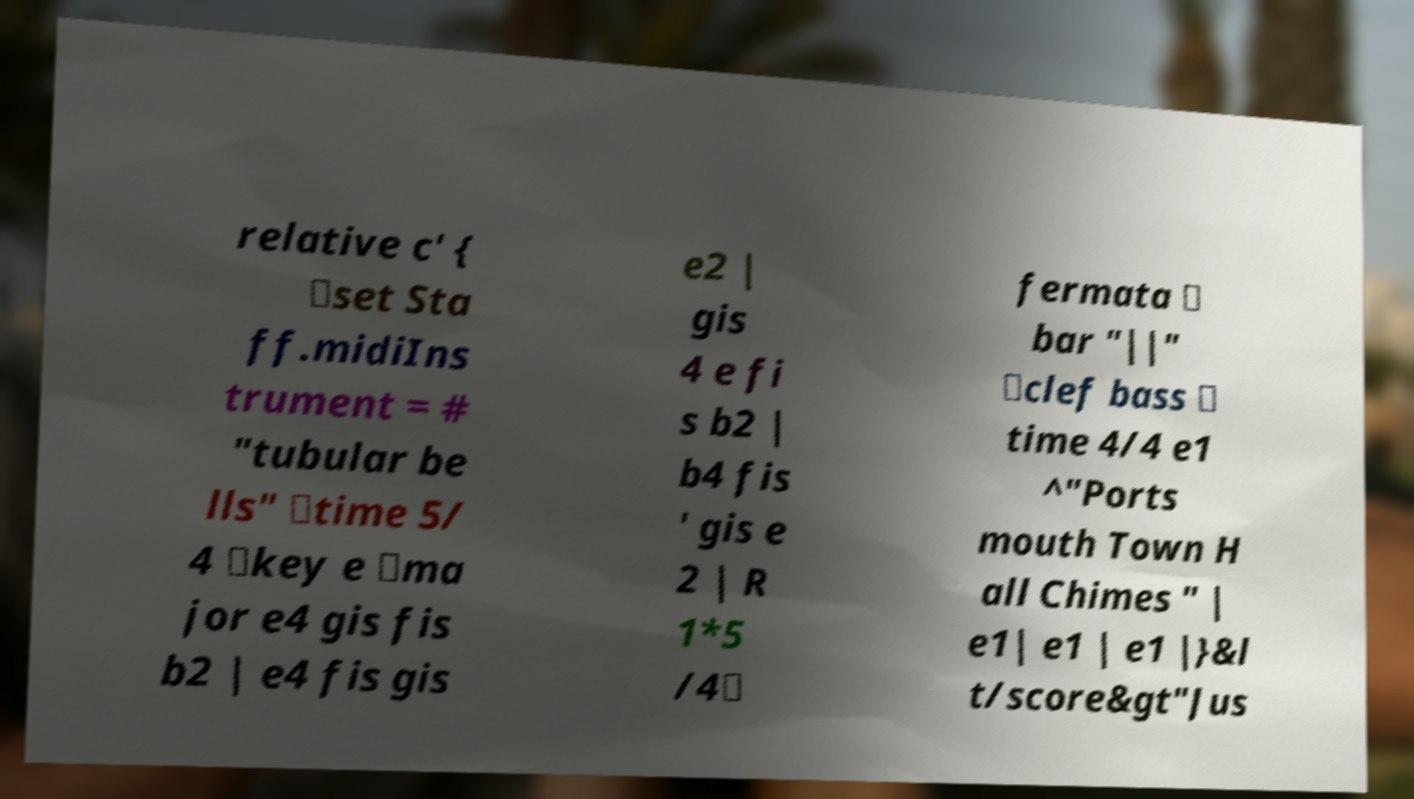I need the written content from this picture converted into text. Can you do that? relative c' { \set Sta ff.midiIns trument = # "tubular be lls" \time 5/ 4 \key e \ma jor e4 gis fis b2 | e4 fis gis e2 | gis 4 e fi s b2 | b4 fis ' gis e 2 | R 1*5 /4\ fermata \ bar "||" \clef bass \ time 4/4 e1 ^"Ports mouth Town H all Chimes " | e1| e1 | e1 |}&l t/score&gt"Jus 